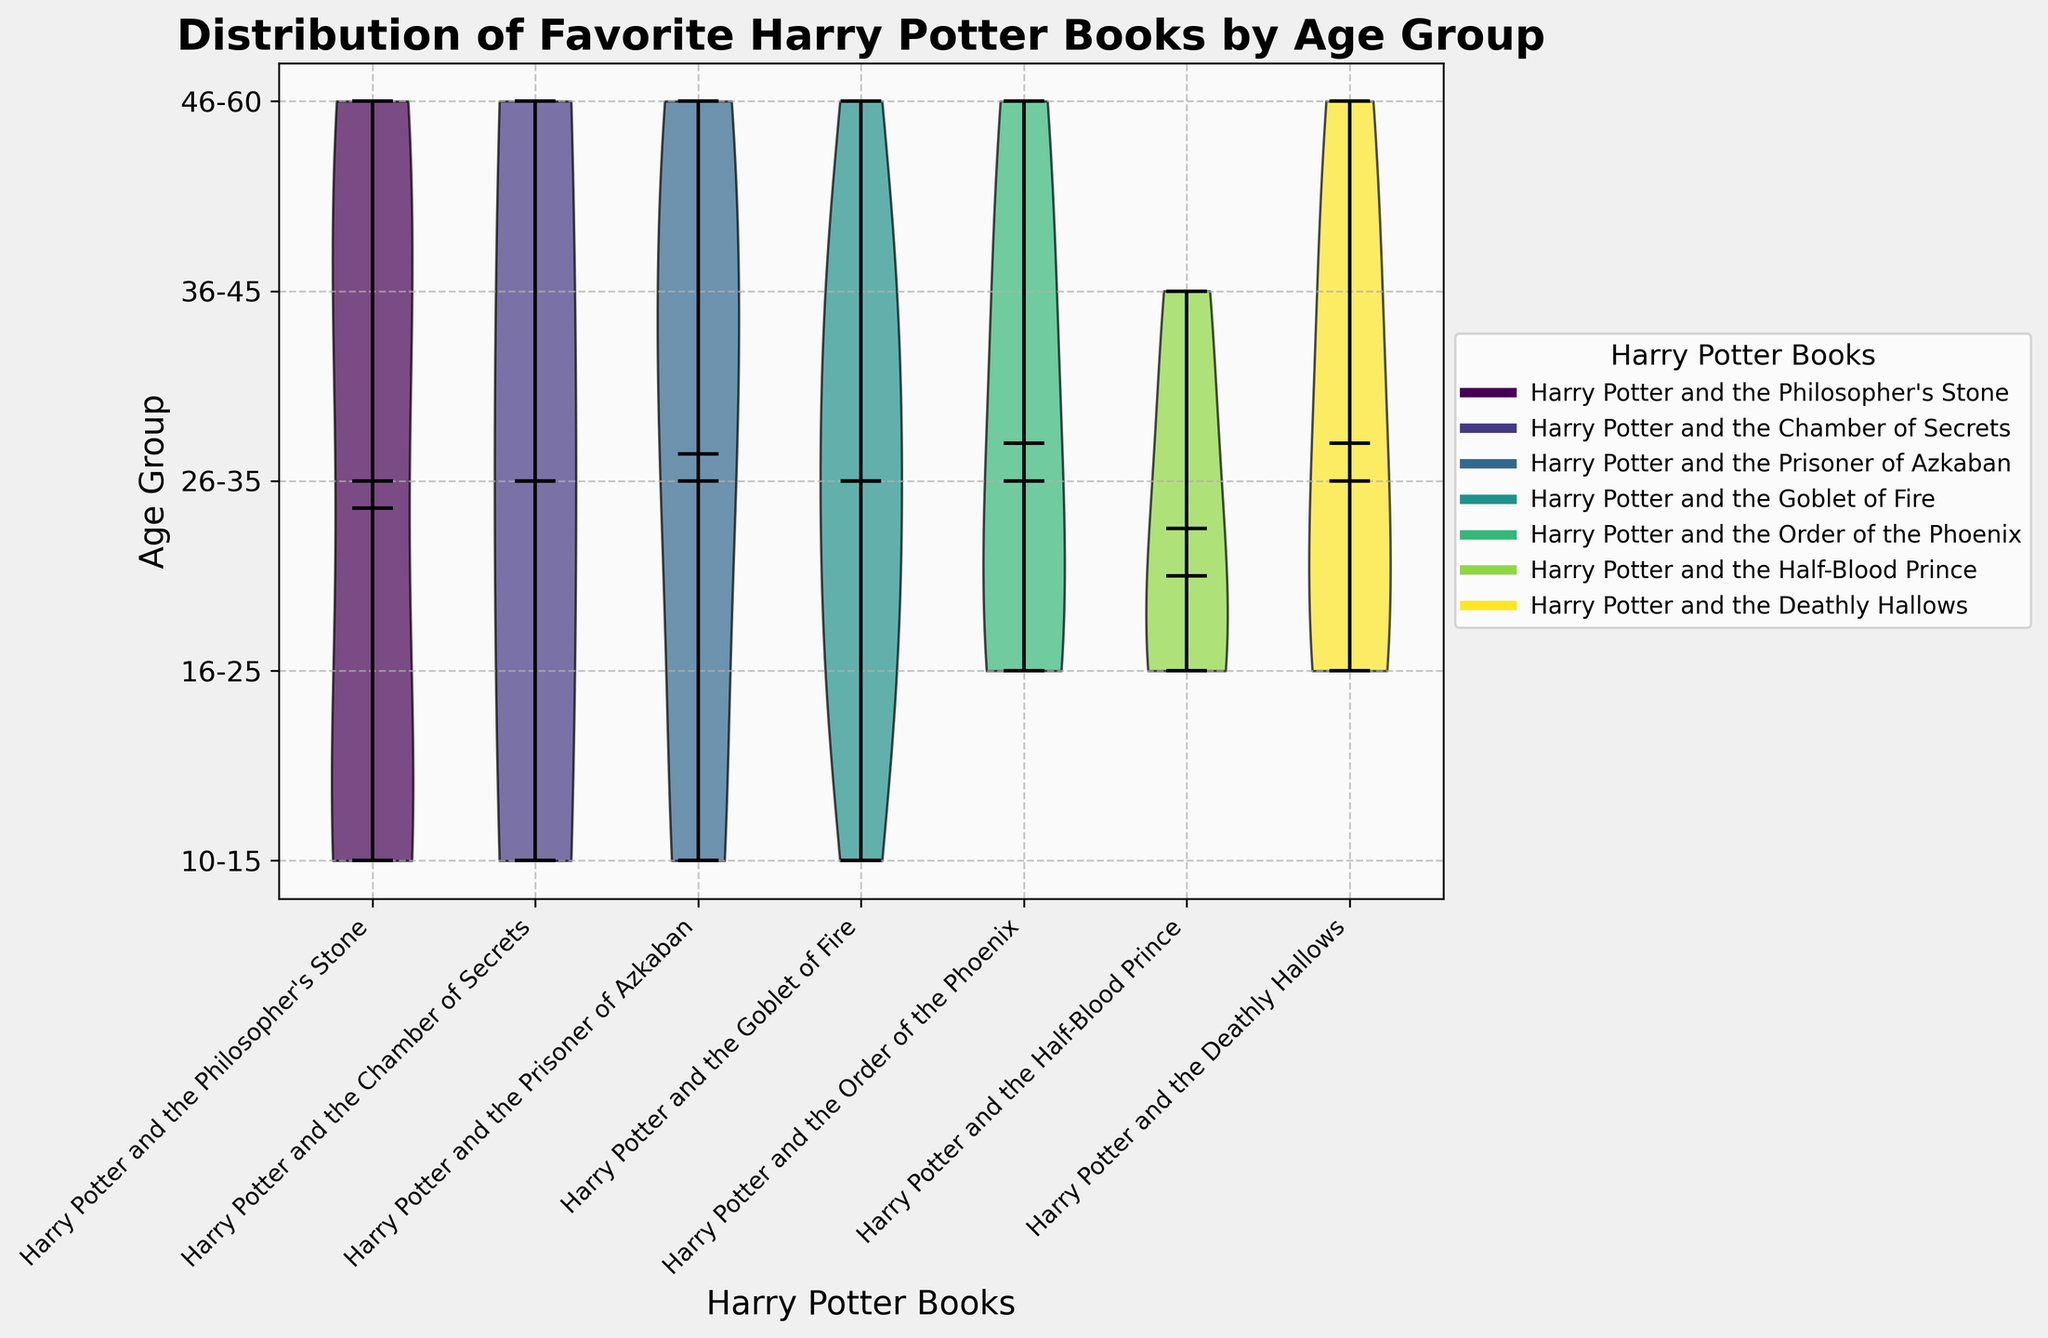Which age group has the greatest variety of favorite books? By looking at the violin chart, we can compare the spread of each age group's favorite books. The broader and more distributed the violins, the more varied the favorite books are.
Answer: 16-25 Which book is favored the most by the age group 10-15? Observing the height and density of the violin plot sections for the age group 10-15, we see a higher density around the "Harry Potter and the Philosopher's Stone" compared to other books.
Answer: Harry Potter and the Philosopher's Stone Which book shows the highest median age group? Identifying the book with the highest median, indicated by the horizontal line within the violins, we see that "Harry Potter and the Deathly Hallows" has a higher median age group compared to others.
Answer: Harry Potter and the Deathly Hallows Is "Harry Potter and the Goblet of Fire" equally favored across all age groups? Examining the width and spread of the violin plots for "Harry Potter and the Goblet of Fire," it is clear that it has noticeable distributions across all age groups except 36-45 and 46-60.
Answer: No Which books have a significant density of preferences from the age group 26-35? Observing the violin sections corresponding to the age group 26-35, we see significant densities for "Harry Potter and the Goblet of Fire" and "Harry Potter and the Prisoner of Azkaban."
Answer: Harry Potter and the Goblet of Fire, Harry Potter and the Prisoner of Azkaban Do any age groups have a strong preference for "Harry Potter and the Chamber of Secrets"? By comparing the violins, we see that "Harry Potter and the Chamber of Secrets" has minimal representation, with no strong preference in any age group.
Answer: No What's the relative preference of "Harry Potter and the Half-Blood Prince" between the age groups 16-25 and 36-45? Viewing the density of the violins for "Harry Potter and the Half-Blood Prince," the age group 16-25 shows a higher density compared to the age group 36-45.
Answer: 16-25 Which age group shows the broadest range in favoring "Harry Potter and the Philosopher's Stone"? The range can be determined by the width and spread of the violin plot for "Harry Potter and the Philosopher's Stone." Age group 46-60 shows the broadest range for this book.
Answer: 46-60 Among age groups 10-15, 16-25, and 26-35, which one has the most peaks in their violin plot sections for various books? Peaks in the violin plot sections indicate a higher number of preferences for various books. Comparing these, the age group 16-25 has the most peaks for multiple books.
Answer: 16-25 